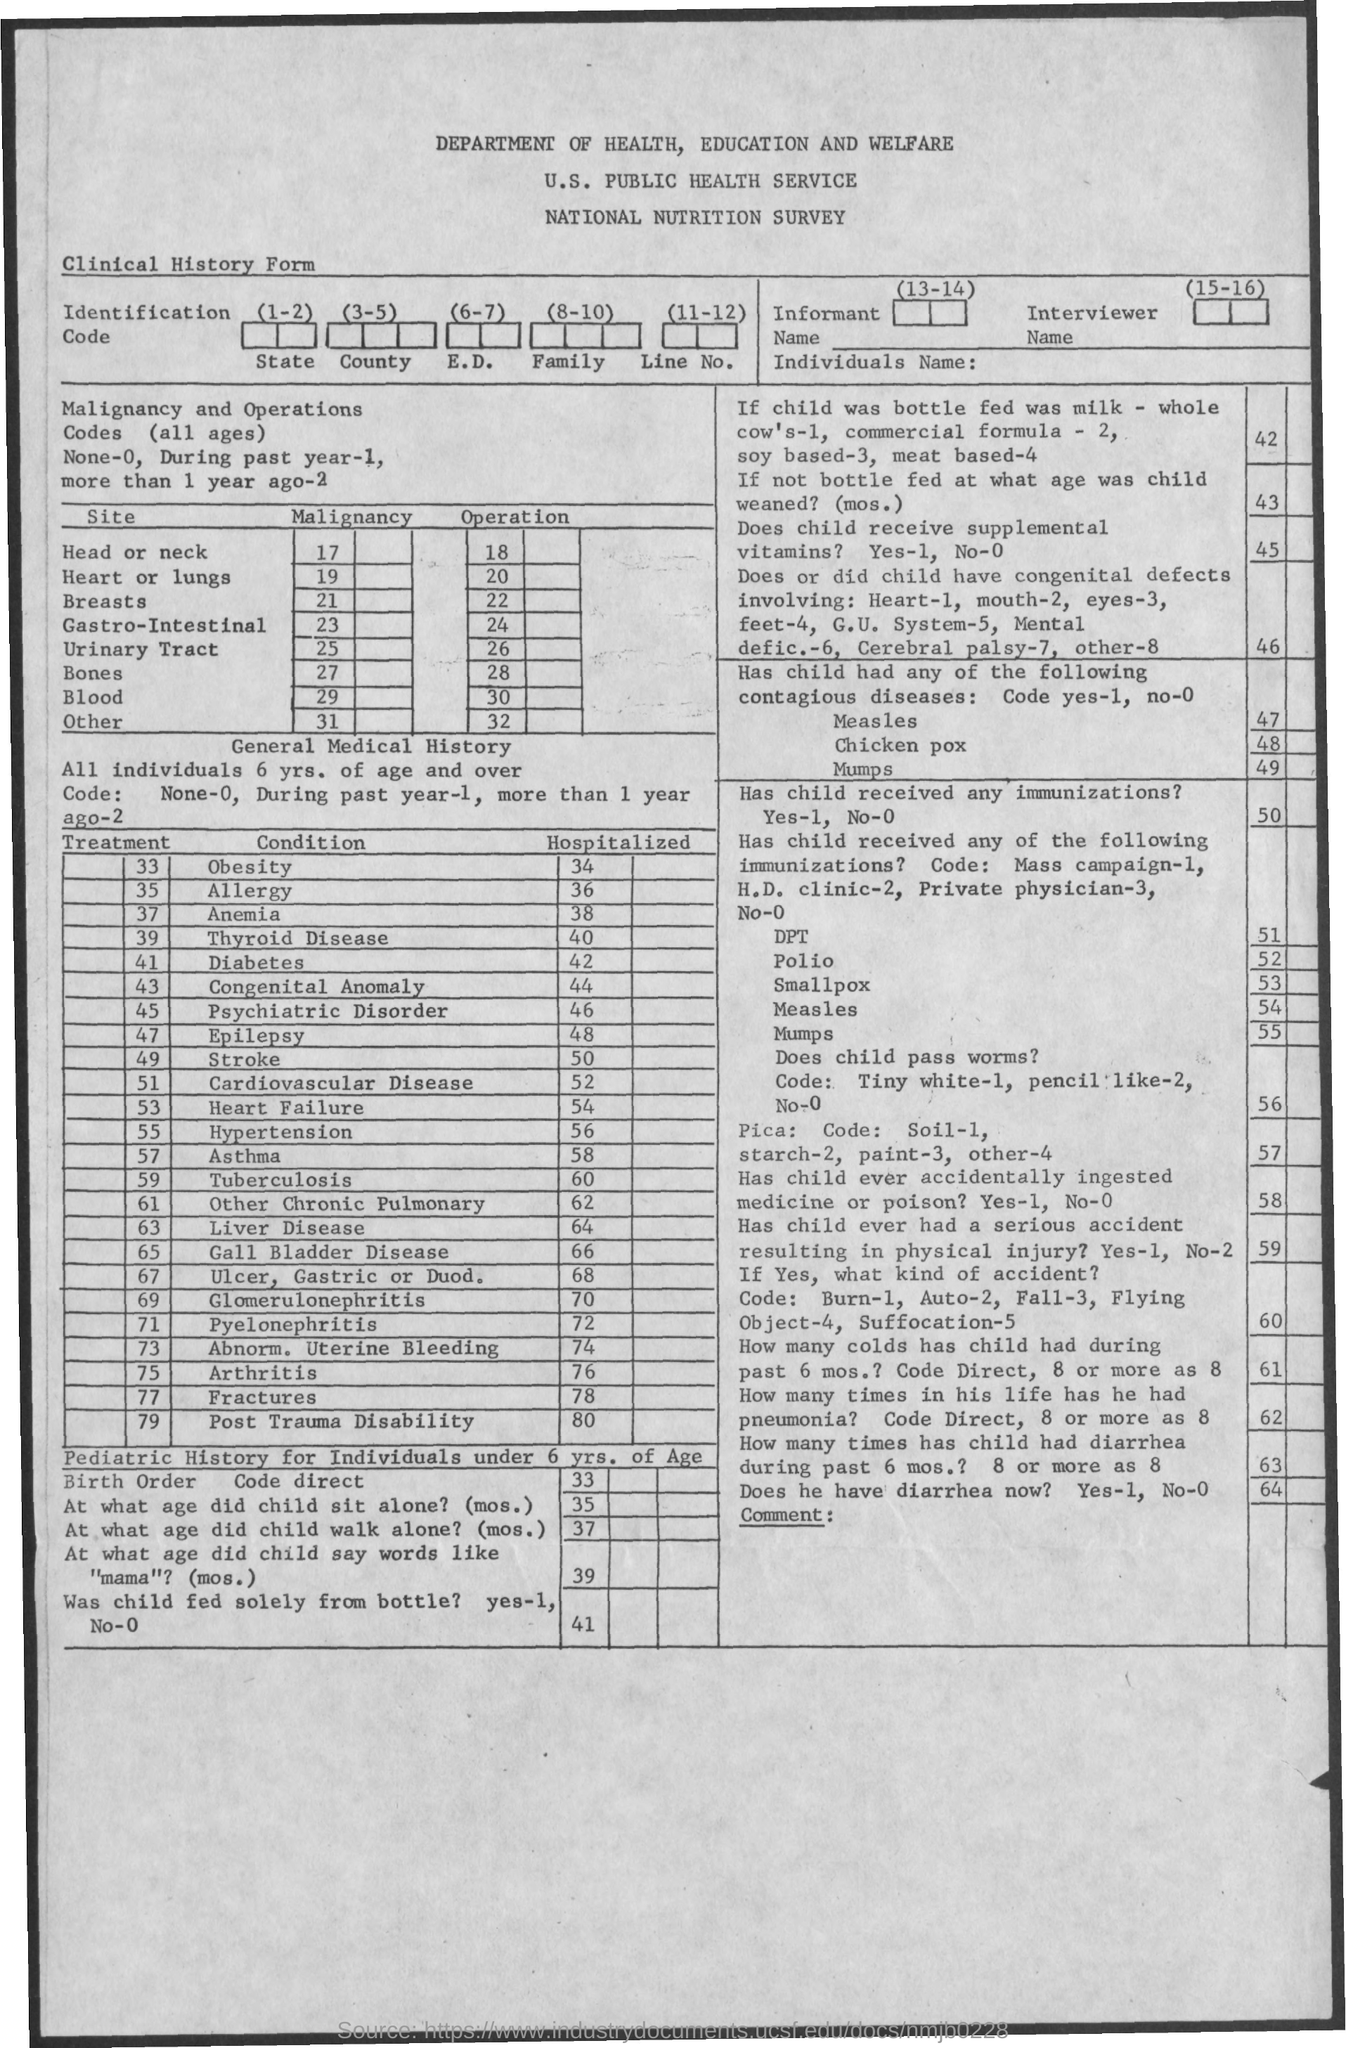How many are Hospitalized for Obesity?
Your response must be concise. 34. How many are Hospitalized for Allergy?
Offer a terse response. 36. How many are Hospitalized for Anemia?
Make the answer very short. 38. How many are Hospitalized for Thyroid Disease?
Make the answer very short. 40. How many are Hospitalized for Diabetes?
Make the answer very short. 42. How many are Hospitalized for Epilepsy?
Offer a very short reply. 48. How many are Hospitalized for Stroke?
Give a very brief answer. 50. How many are Hospitalized for Asthma?
Offer a very short reply. 58. How many are Hospitalized for Tubercolis?
Your answer should be compact. 60. How many are Hospitalized for Liver Disease?
Provide a short and direct response. 64. 